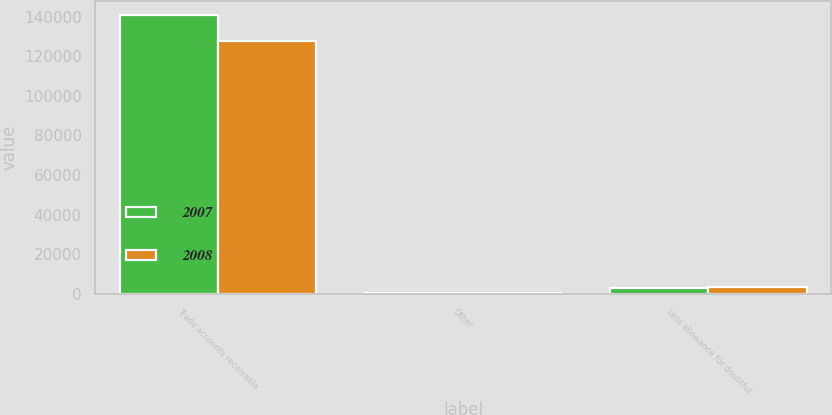Convert chart. <chart><loc_0><loc_0><loc_500><loc_500><stacked_bar_chart><ecel><fcel>Trade accounts receivable<fcel>Other<fcel>Less allowance for doubtful<nl><fcel>2007<fcel>140966<fcel>505<fcel>3152<nl><fcel>2008<fcel>127467<fcel>636<fcel>3544<nl></chart> 